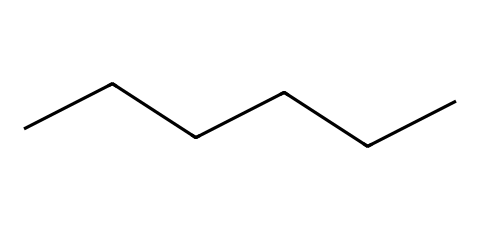What is the name of this chemical? The structure represented by the SMILES is composed of six carbon atoms in a straight chain, which is characteristic of hexane.
Answer: hexane How many carbon atoms are in this molecule? The SMILES indicates a linear arrangement of six carbon atoms, which can be counted directly from the string "CCCCCC."
Answer: six What type of bonds are present in hexane? Hexane contains only single bonds between the carbon atoms in its linear structure, indicated by the absence of double or triple bond symbols in the SMILES.
Answer: single bonds What is the molecular formula of hexane? By counting the carbon and hydrogen atoms in hexane, which has six carbon atoms and fourteen hydrogen atoms (C6H14), we derive its molecular formula.
Answer: C6H14 Why is hexane commonly used in oil extraction? Hexane is a non-polar solvent, which allows it to effectively dissolve oils and fats, making it ideal for extracting animal and vegetable oils.
Answer: non-polar solvent What type of chemical is hexane classified as? Hexane is classified as an alkane due to its saturated nature, consisting solely of carbon and hydrogen atoms with single bonds.
Answer: alkane How does the structure of hexane affect its boiling point compared to shorter alkanes? The longer carbon chain of hexane increases the surface area for van der Waals forces, leading to a higher boiling point compared to shorter alkanes.
Answer: higher boiling point 